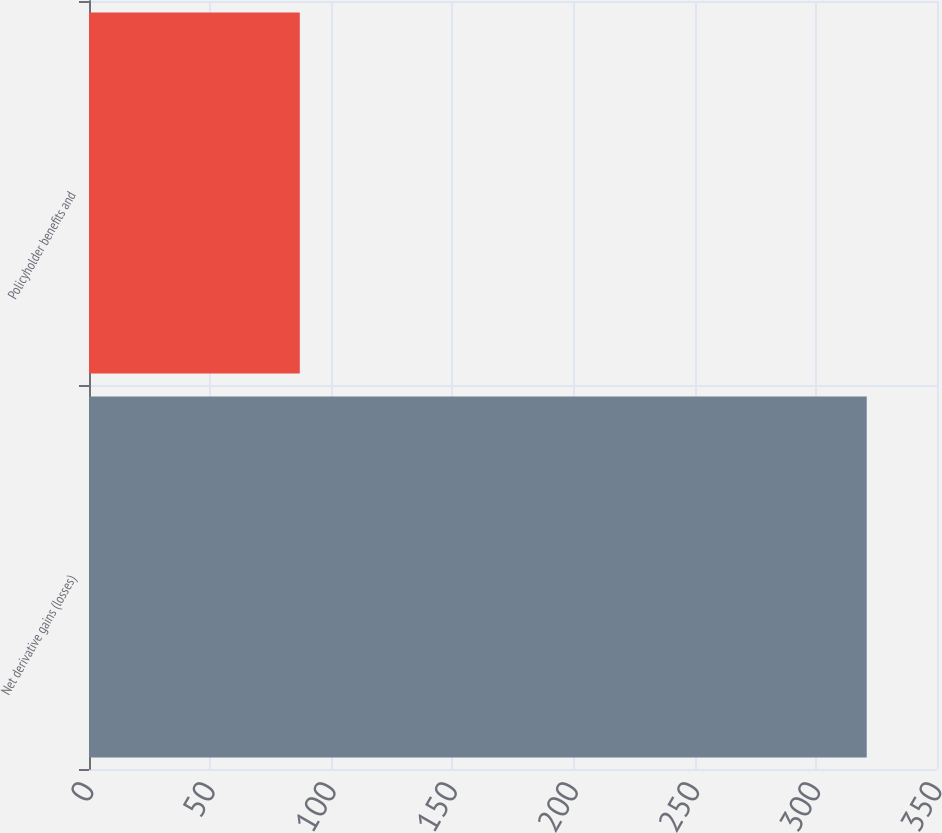Convert chart to OTSL. <chart><loc_0><loc_0><loc_500><loc_500><bar_chart><fcel>Net derivative gains (losses)<fcel>Policyholder benefits and<nl><fcel>321<fcel>87<nl></chart> 